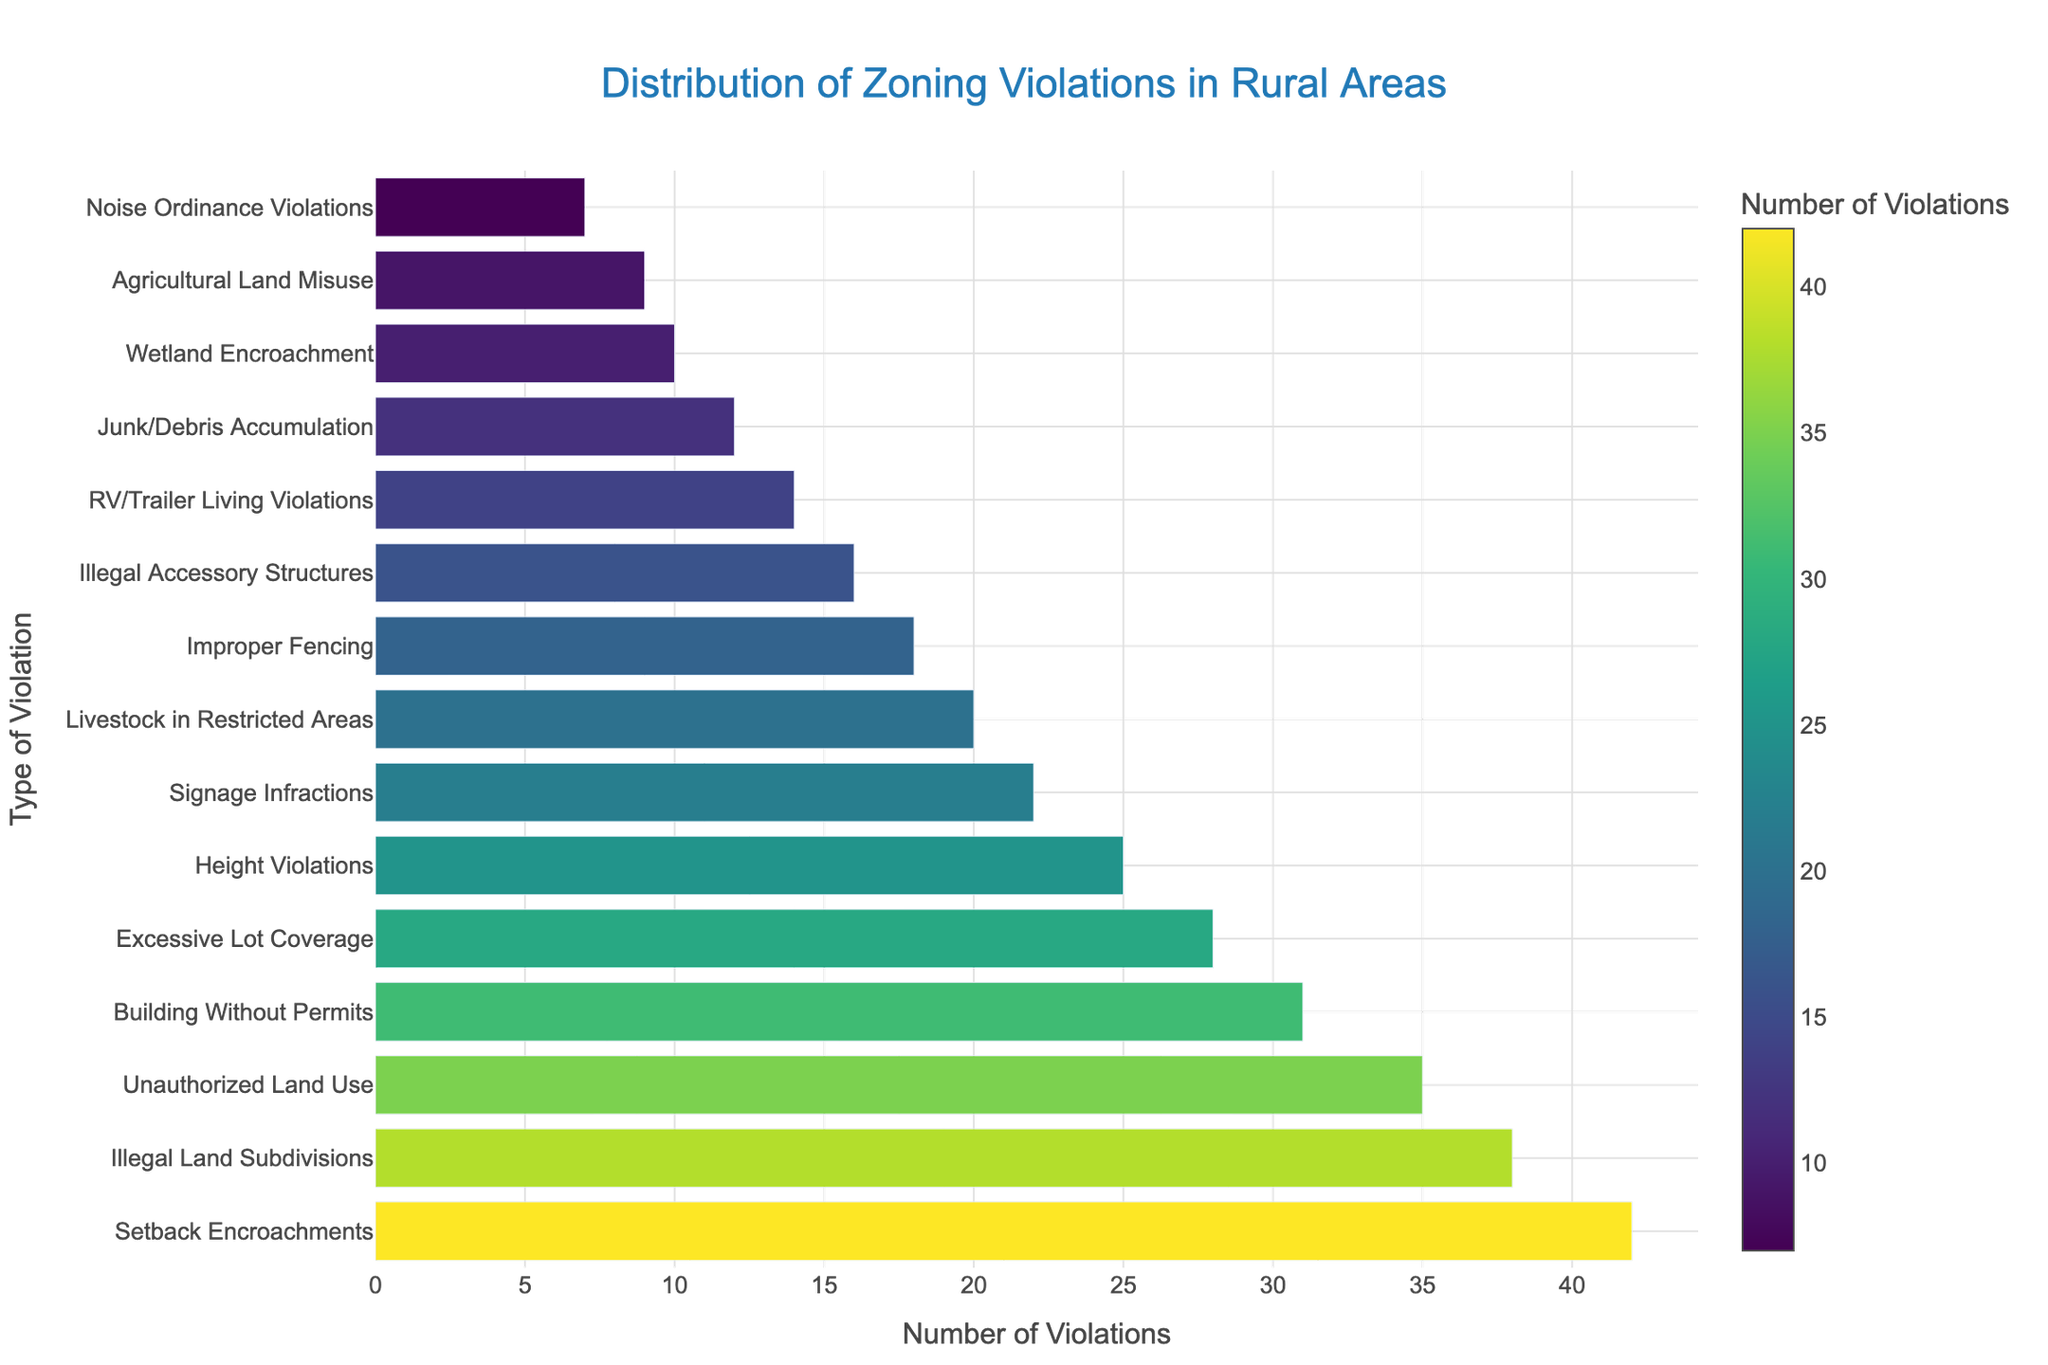Which type of zoning violation has the highest number of violations? The highest bar indicates the type with the most violations. "Setback Encroachments" has the tallest bar which corresponds to 42 violations.
Answer: Setback Encroachments How many more violations does "Setback Encroachments" have compared to "Noise Ordinance Violations"? Identify the bar for each type and subtract the shorter bar's value (Noise Ordinance Violations = 7) from the taller bar's value (Setback Encroachments = 42). 42 - 7 = 35
Answer: 35 Which types of violations have more than 30 violations? Find the bars that extend past the 30-mark on the x-axis. "Setback Encroachments", "Illegal Land Subdivisions", "Unauthorized Land Use", and "Building Without Permits" have more than 30 violations.
Answer: Setback Encroachments, Illegal Land Subdivisions, Unauthorized Land Use, Building Without Permits What is the difference in the number of violations between "Signage Infractions" and "Junk/Debris Accumulation"? Locate the bars for each type and subtract the value of the shorter bar (Junk/Debris Accumulation = 12) from the taller bar (Signage Infractions = 22). 22 - 12 = 10
Answer: 10 Which type of zoning violation is less frequent than "Wetland Encroachment" but more frequent than "Noise Ordinance Violations"? Find "Wetland Encroachment" (10) on the y-axis and see which bar lies between 10 and 7 (Noise Ordinance Violations). Only "Agricultural Land Misuse" with 9 violations fits.
Answer: Agricultural Land Misuse Which type of violation has exactly 16 reports? Identify the bar that reaches up to exactly 16 on the x-axis. The bar for "Illegal Accessory Structures" corresponds to 16 violations.
Answer: Illegal Accessory Structures What is the total number of violations for "Excessive Lot Coverage", "Height Violations", and "Signage Infractions"? Sum the values of the bars for these types: Excessive Lot Coverage (28) + Height Violations (25) + Signage Infractions (22). Thus, 28 + 25 + 22 = 75.
Answer: 75 Which violation type is visually represented with the shortest bar? Identify the shortest bar on the graph which corresponds to "Noise Ordinance Violations" with 7 violations.
Answer: Noise Ordinance Violations How many violations in total are reported for the bottom three violation types? Sum the number of violations for the last three types: Wetland Encroachment (10) + Agricultural Land Misuse (9) + Noise Ordinance Violations (7). So, 10 + 9 + 7 = 26.
Answer: 26 